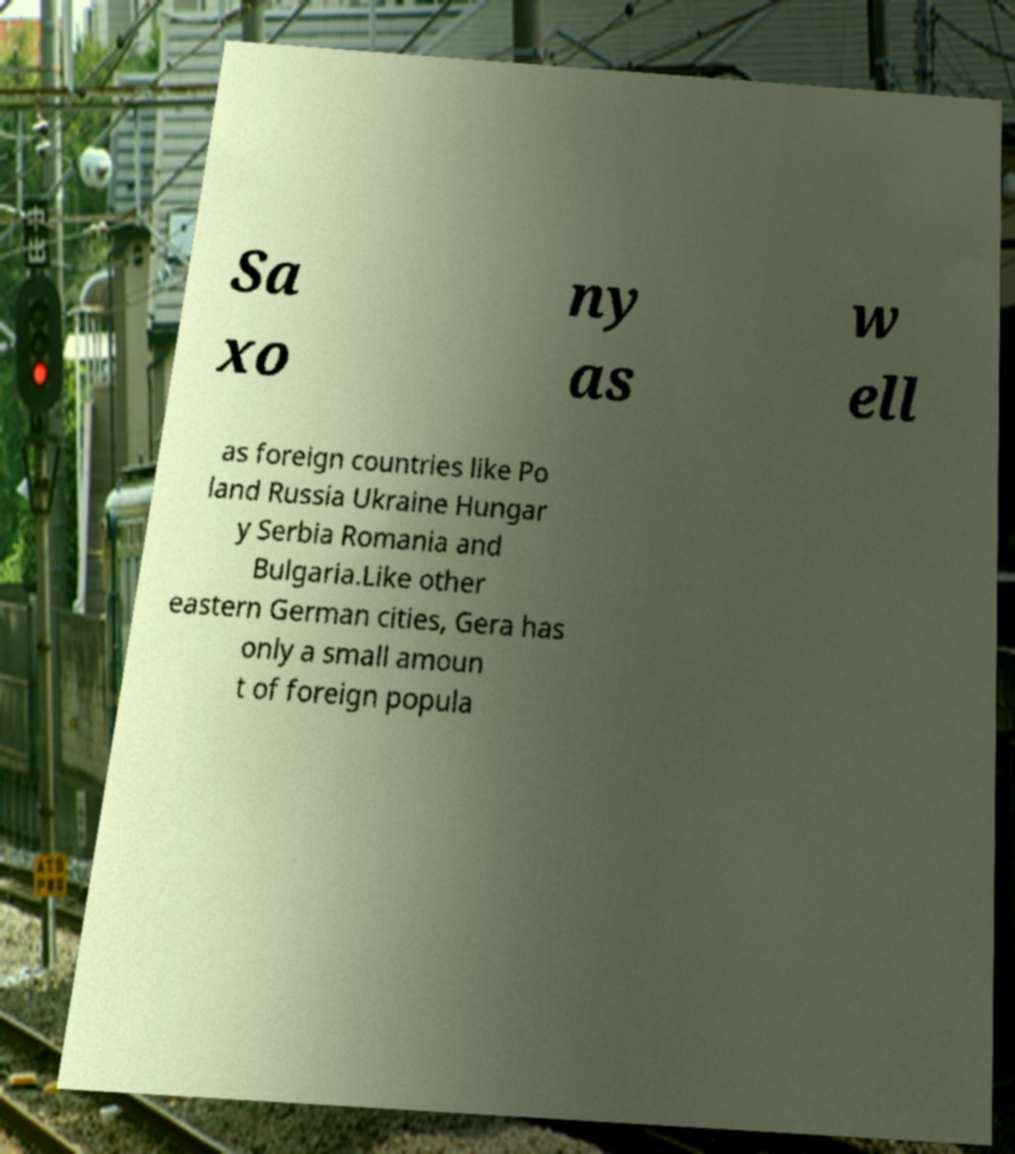There's text embedded in this image that I need extracted. Can you transcribe it verbatim? Sa xo ny as w ell as foreign countries like Po land Russia Ukraine Hungar y Serbia Romania and Bulgaria.Like other eastern German cities, Gera has only a small amoun t of foreign popula 